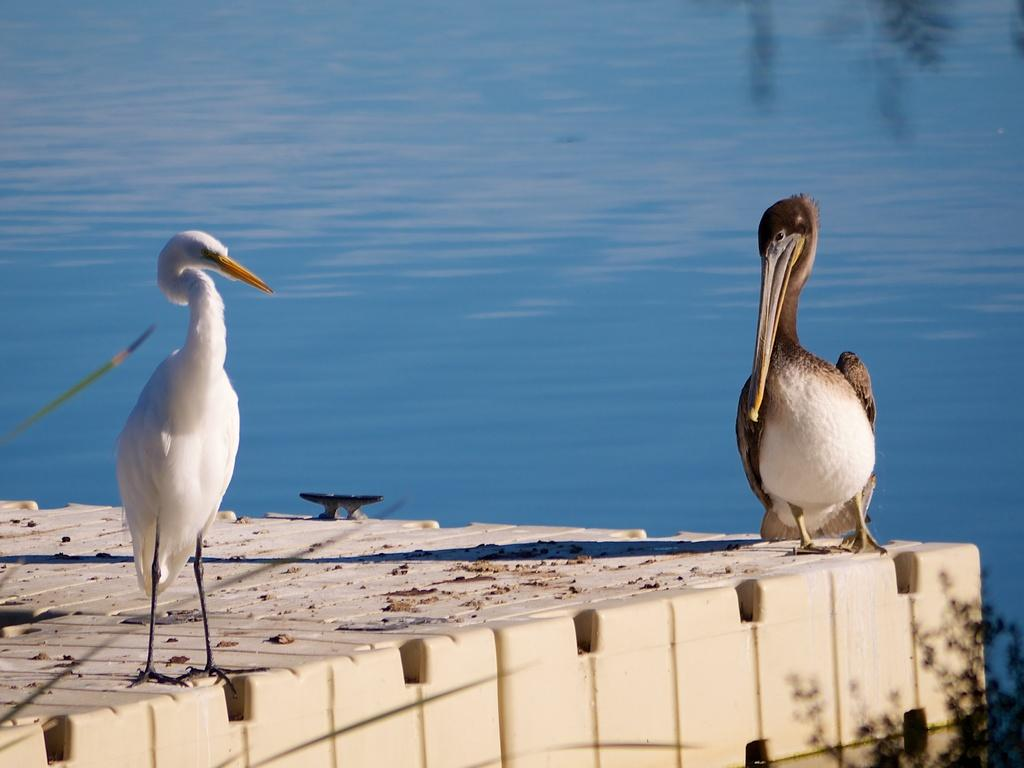What animals can be seen in the front of the image? There are two birds in the front of the image. What natural element is visible in the background of the image? There is water visible in the background of the image. What type of plant is present at the right bottom of the image? There are leaves of a plant at the right bottom of the image. What type of fang can be seen in the image? There is no fang present in the image. What type of flower is visible in the image? There is no flower visible in the image. 